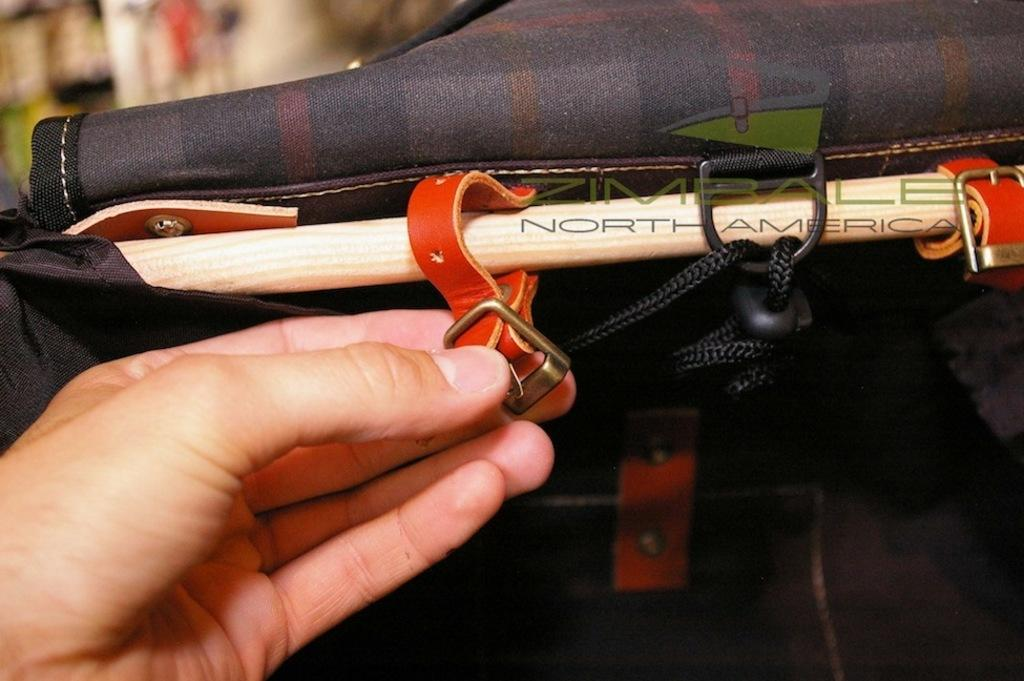What part of a person's body is visible in the image? There is a person's hand in the image. What object is near the person's hand? There is an object that looks like a bag in the image. What color is the object near the bag? There is a white color object near the bag in the image. Can you see any fangs on the person's hand in the image? There are no fangs visible on the person's hand in the image. What type of vegetable is connected to the bag in the image? There is no vegetable connected to the bag in the image. 